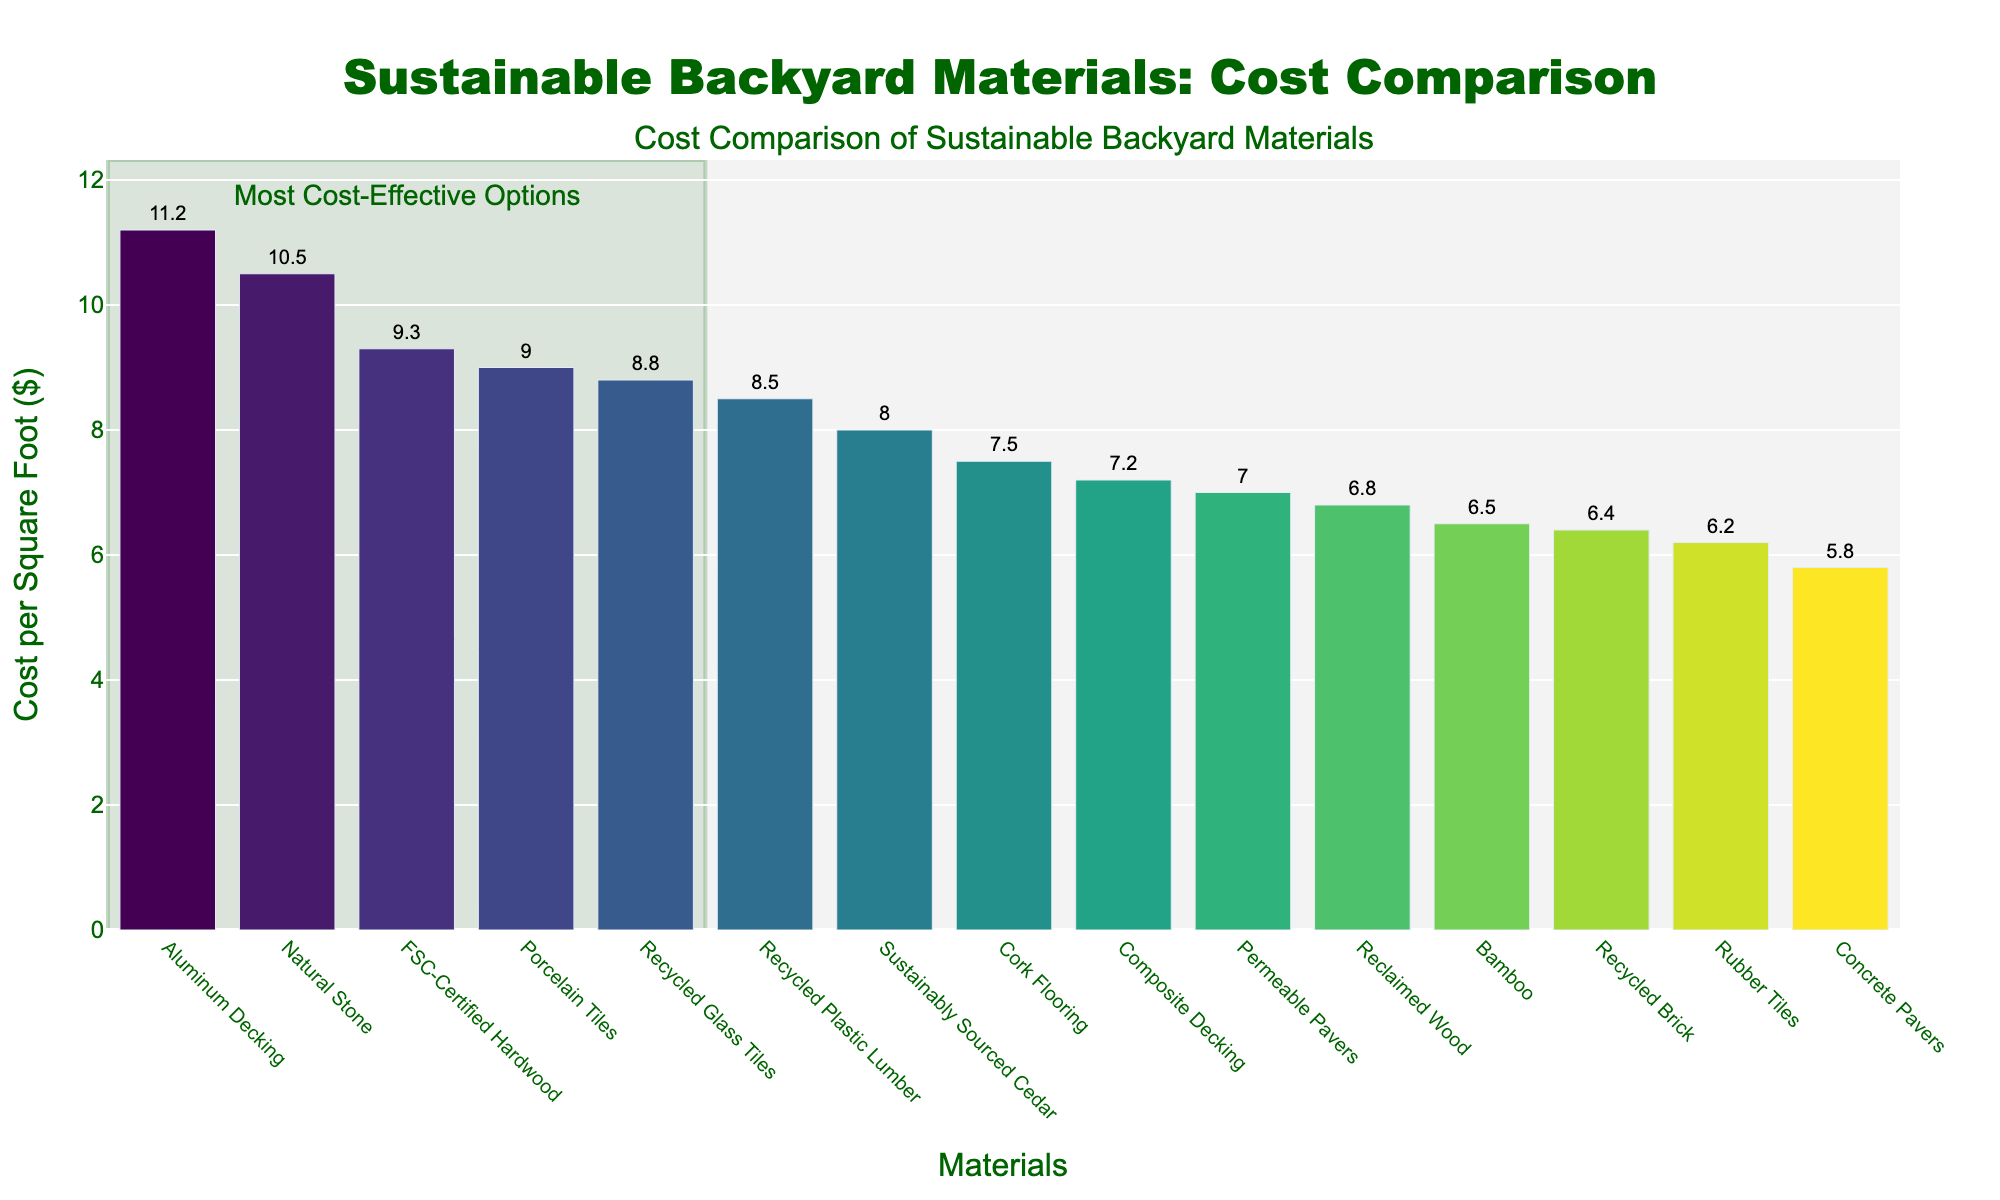Which material has the highest cost per square foot? By looking at the heights of the bars, we identify the tallest bar representing the material with the highest cost per square foot. The tallest bar on the chart is for Aluminum Decking.
Answer: Aluminum Decking Which material has the lowest cost per square foot? To find the material with the lowest cost per square foot, we look for the shortest bar in the chart. The shortest bar represents Concrete Pavers.
Answer: Concrete Pavers What is the combined cost per square foot of Bamboo and Recycled Brick? To find the combined cost, add the cost per square foot of Bamboo ($6.50) and Recycled Brick ($6.40). The sum is $6.50 + $6.40.
Answer: 12.90 Which materials cost less than $7.00 per square foot? We look at the bars that are below the $7.00 per square foot mark. These materials are Reclaimed Wood, Bamboo, Concrete Pavers, Rubber Tiles, and Recycled Brick.
Answer: Reclaimed Wood, Bamboo, Concrete Pavers, Rubber Tiles, Recycled Brick How much more expensive is Aluminum Decking compared to FSC-Certified Hardwood? The cost of Aluminum Decking is $11.20 per square foot while FSC-Certified Hardwood costs $9.30 per square foot. Subtract the cost of FSC-Certified Hardwood from Aluminum Decking to find the difference: $11.20 - $9.30.
Answer: 1.90 Which materials fall within the most cost-effective options highlighted in the chart? The highlighted rectangle indicates the most cost-effective options. These fall within the lower half of the cost range. The materials are Reclaimed Wood, Bamboo, Concrete Pavers, Rubber Tiles, and Recycled Brick.
Answer: Reclaimed Wood, Bamboo, Concrete Pavers, Rubber Tiles, Recycled Brick What's the average cost per square foot of the top three most expensive materials? The top three most expensive materials are Aluminum Decking ($11.20), Natural Stone ($10.50), and FSC-Certified Hardwood ($9.30). To find the average, sum their costs and divide by three: ($11.20 + $10.50 + $9.30) / 3.
Answer: 10.33 How much more expensive is Recycled Glass Tiles compared to Composite Decking? The cost of Recycled Glass Tiles is $8.80 per square foot while Composite Decking is $7.20 per square foot. Subtract the cost of Composite Decking from Recycled Glass Tiles to find the difference: $8.80 - $7.20.
Answer: 1.60 Which materials have costs between $7.00 and $8.00 per square foot? By visually scanning the bars within the $7.00 to $8.00 range, the materials found are Composite Decking, Permeable Pavers, and Cork Flooring.
Answer: Composite Decking, Permeable Pavers, Cork Flooring 